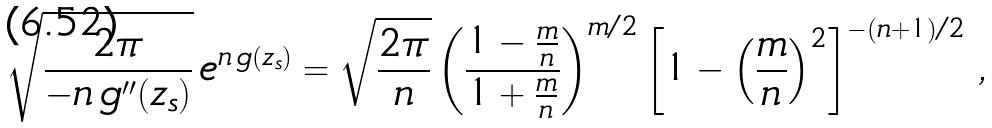Convert formula to latex. <formula><loc_0><loc_0><loc_500><loc_500>\sqrt { \frac { 2 \pi } { - n \, g ^ { \prime \prime } ( z _ { s } ) } } \, e ^ { n \, g ( z _ { s } ) } = \sqrt { \frac { 2 \pi } { n } } \left ( \frac { 1 - \frac { m } { n } } { 1 + \frac { m } { n } } \right ) ^ { m / 2 } \left [ 1 - \left ( \frac { m } { n } \right ) ^ { 2 } \right ] ^ { - ( n + 1 ) / 2 } \, ,</formula> 